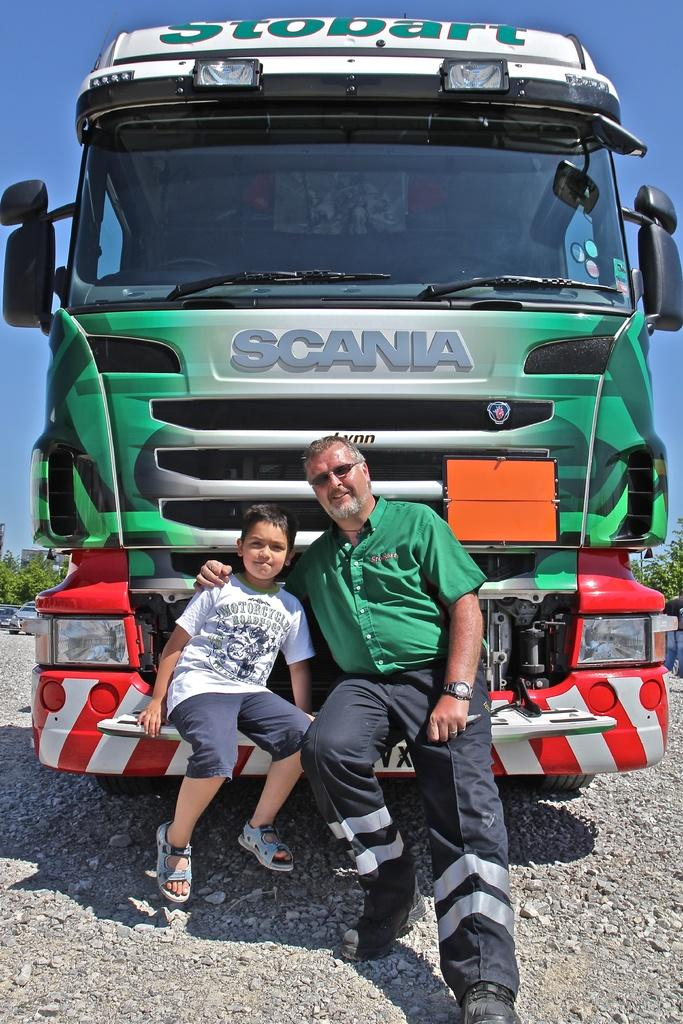Who is present in the image? There is a person and a child in the image. What are they doing in the image? Both the person and the child are sitting on the front part of a vehicle. What can be seen in the background of the image? There are vehicles, trees, buildings, and the sky visible in the background of the image. What type of comfort can be seen being offered to the child in the image? There is no indication of comfort being offered to the child in the image; they are simply sitting on the front part of a vehicle. What type of pickle is being used as a prop in the image? There is no pickle present in the image. 